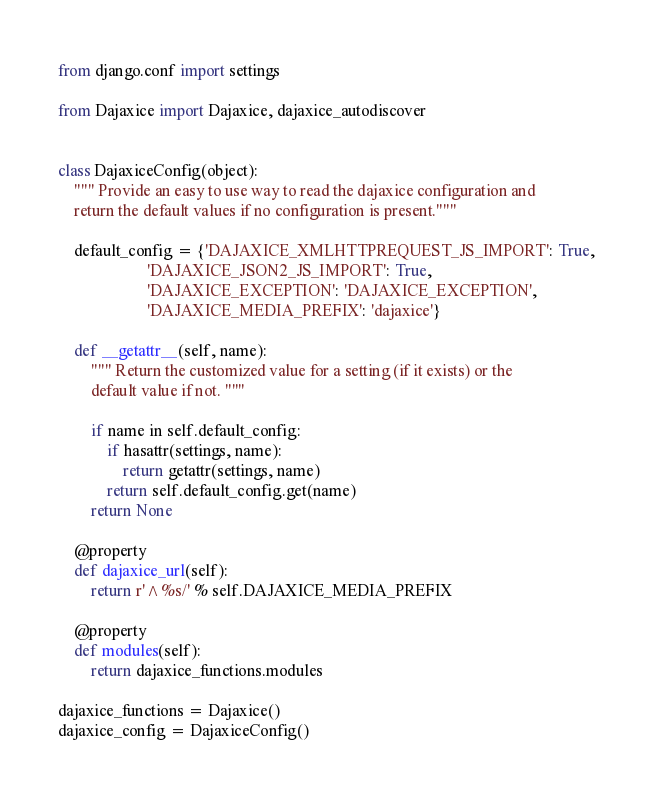<code> <loc_0><loc_0><loc_500><loc_500><_Python_>from django.conf import settings

from Dajaxice import Dajaxice, dajaxice_autodiscover


class DajaxiceConfig(object):
    """ Provide an easy to use way to read the dajaxice configuration and
    return the default values if no configuration is present."""

    default_config = {'DAJAXICE_XMLHTTPREQUEST_JS_IMPORT': True,
                      'DAJAXICE_JSON2_JS_IMPORT': True,
                      'DAJAXICE_EXCEPTION': 'DAJAXICE_EXCEPTION',
                      'DAJAXICE_MEDIA_PREFIX': 'dajaxice'}

    def __getattr__(self, name):
        """ Return the customized value for a setting (if it exists) or the
        default value if not. """

        if name in self.default_config:
            if hasattr(settings, name):
                return getattr(settings, name)
            return self.default_config.get(name)
        return None

    @property
    def dajaxice_url(self):
        return r'^%s/' % self.DAJAXICE_MEDIA_PREFIX

    @property
    def modules(self):
        return dajaxice_functions.modules

dajaxice_functions = Dajaxice()
dajaxice_config = DajaxiceConfig()
</code> 